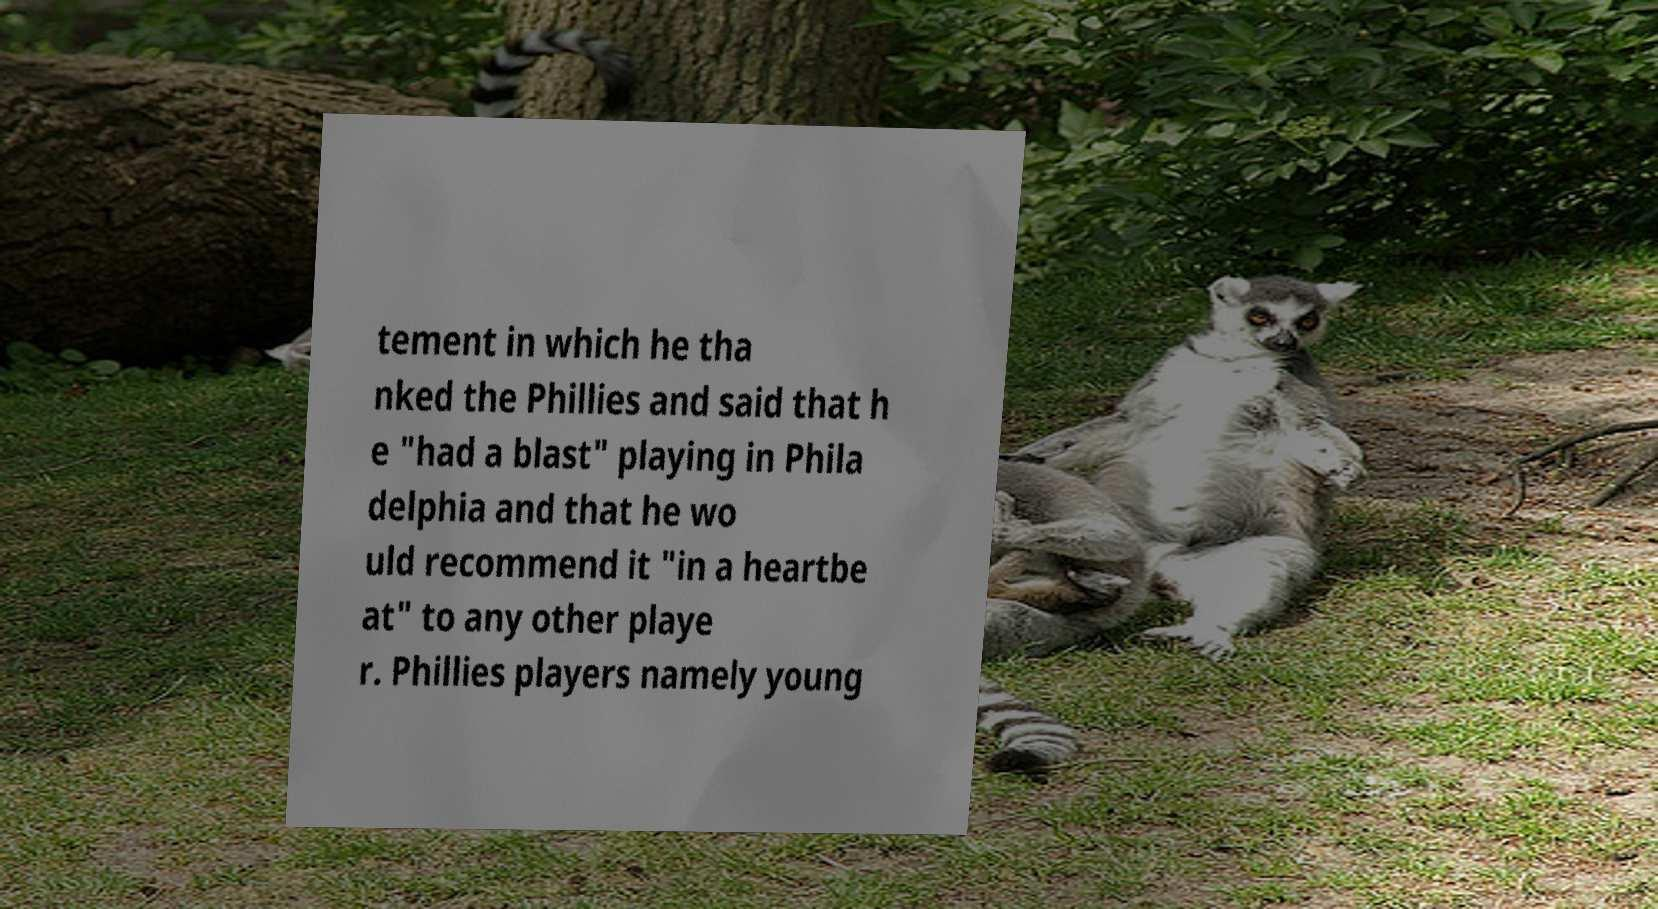Can you read and provide the text displayed in the image?This photo seems to have some interesting text. Can you extract and type it out for me? tement in which he tha nked the Phillies and said that h e "had a blast" playing in Phila delphia and that he wo uld recommend it "in a heartbe at" to any other playe r. Phillies players namely young 